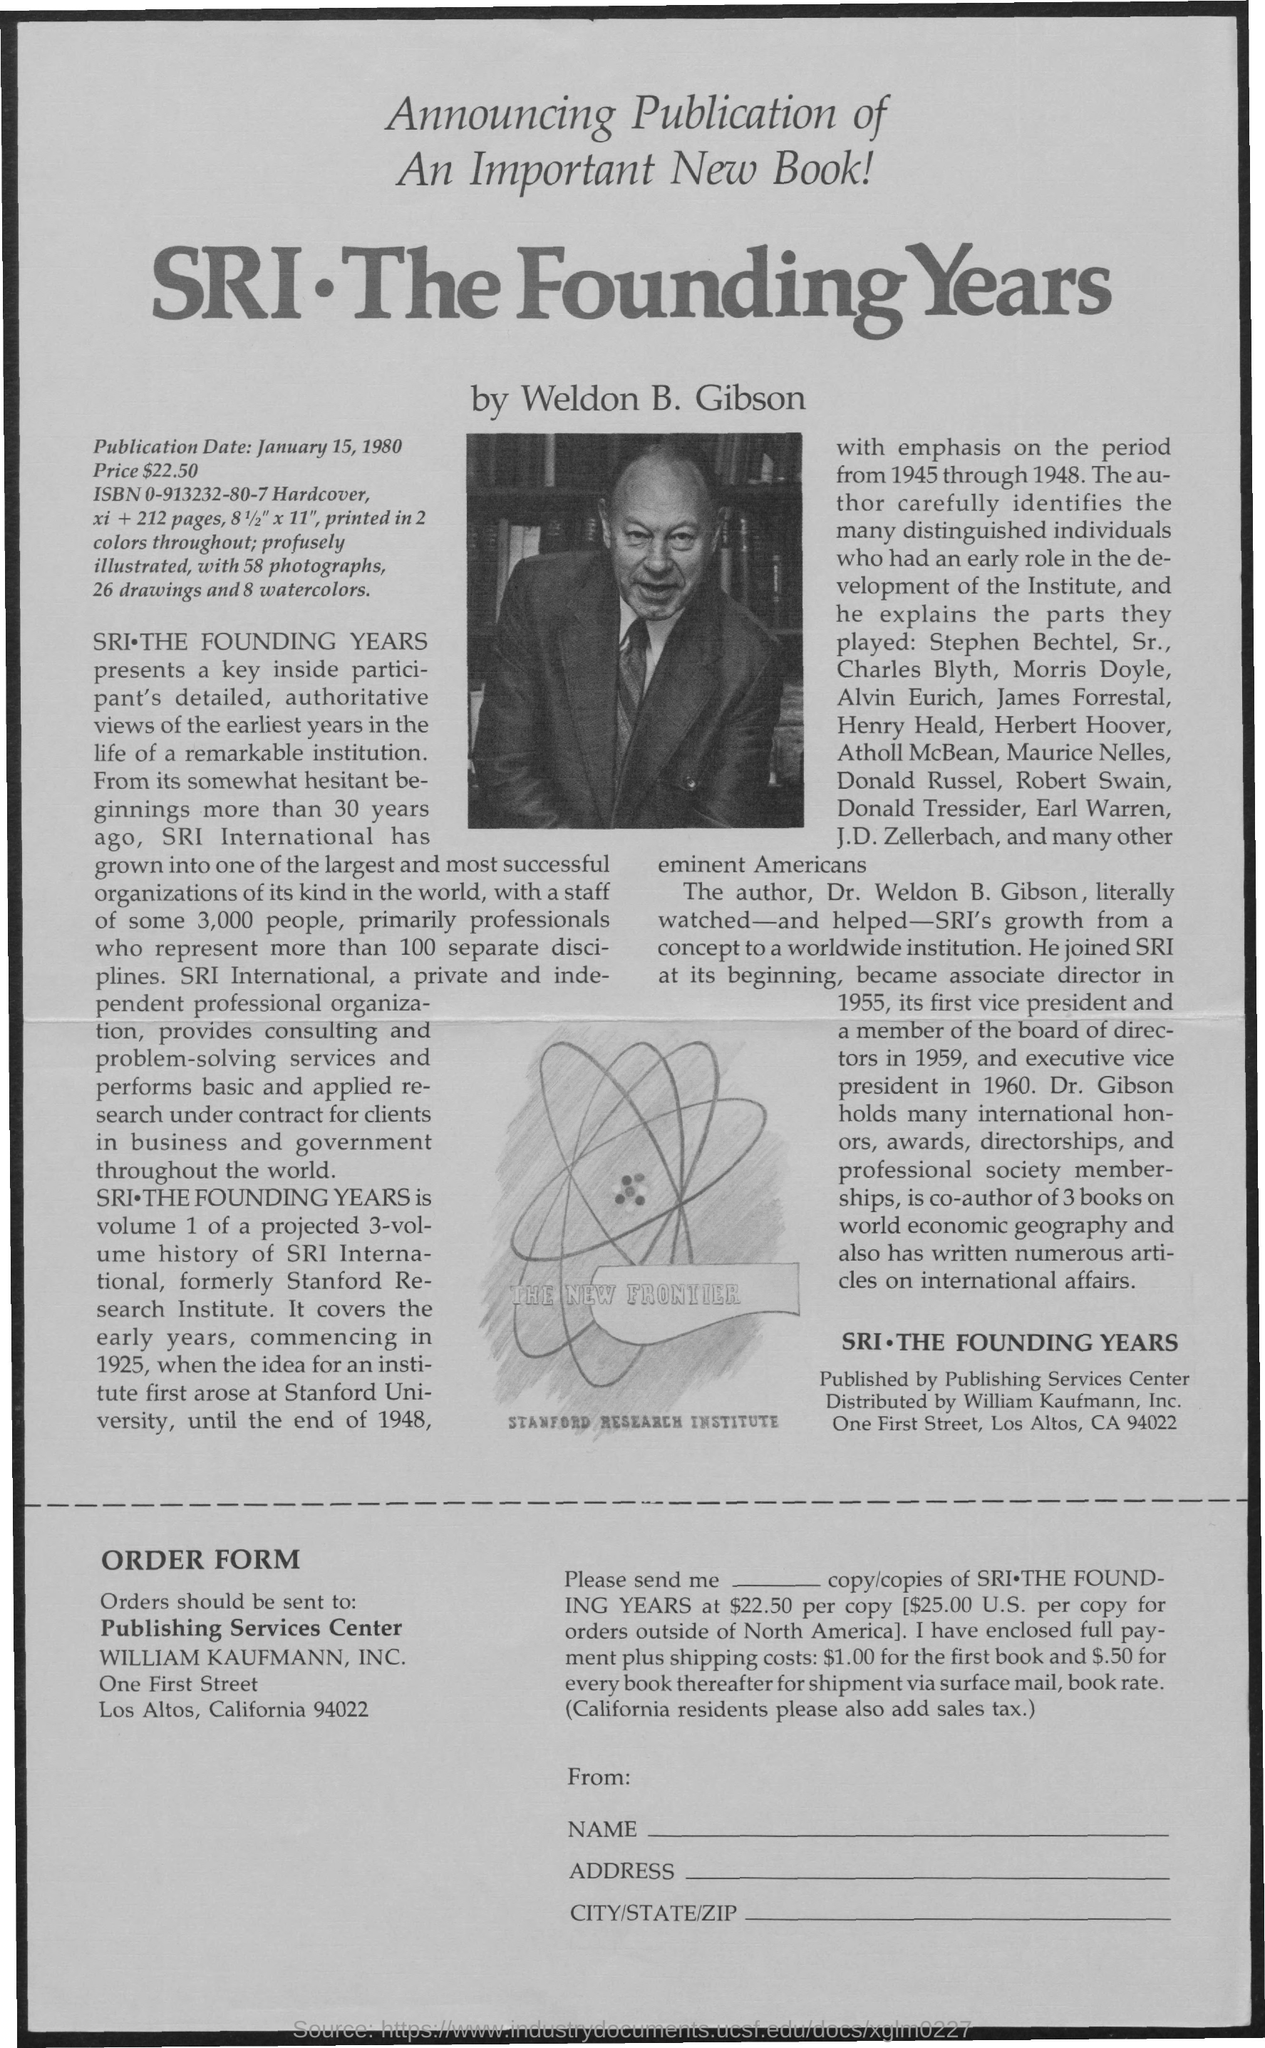What is the Publication Date ?
Make the answer very short. January 15, 1980. 